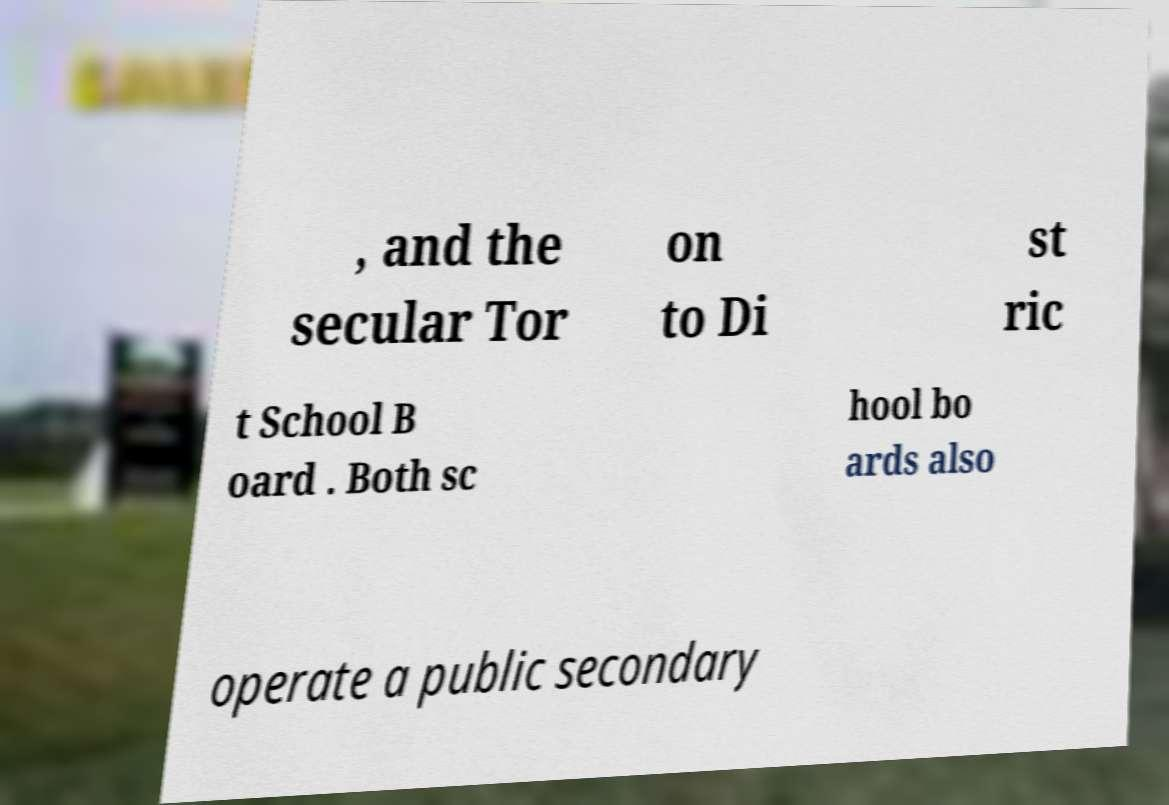Could you assist in decoding the text presented in this image and type it out clearly? , and the secular Tor on to Di st ric t School B oard . Both sc hool bo ards also operate a public secondary 